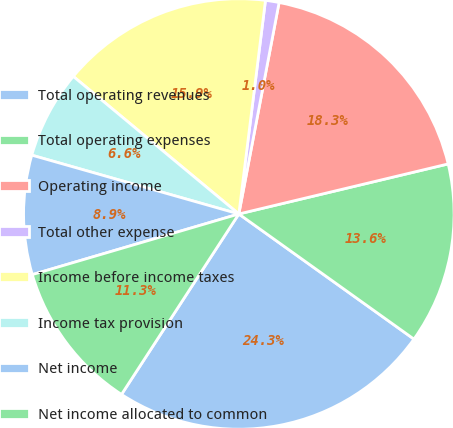Convert chart to OTSL. <chart><loc_0><loc_0><loc_500><loc_500><pie_chart><fcel>Total operating revenues<fcel>Total operating expenses<fcel>Operating income<fcel>Total other expense<fcel>Income before income taxes<fcel>Income tax provision<fcel>Net income<fcel>Net income allocated to common<nl><fcel>24.3%<fcel>13.61%<fcel>18.27%<fcel>1.02%<fcel>15.94%<fcel>6.63%<fcel>8.95%<fcel>11.28%<nl></chart> 